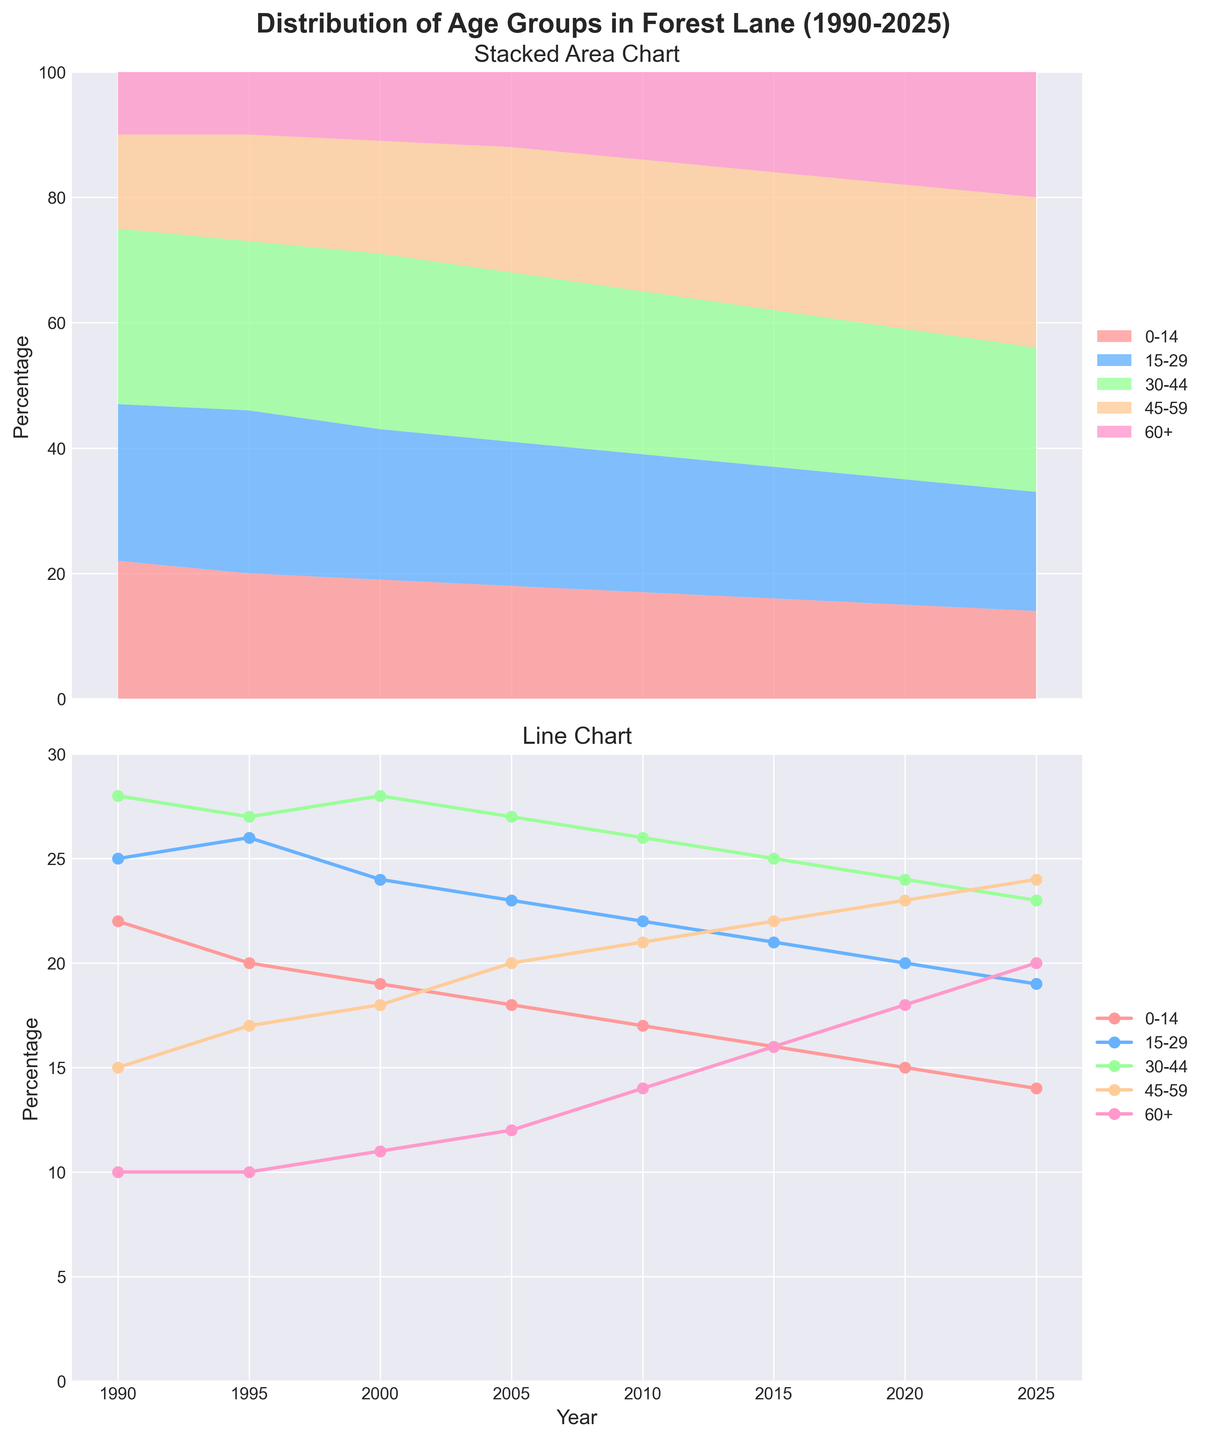What age group experienced the largest increase in percentage from 1990 to 2025? To find the age group with the largest increase, subtract the 1990 percentage from the 2025 percentage for each group: (14-22)=(-8); (19-25)=(-6); (23-28)=(-5); (24-15)=(9); (20-10)=(10). The 60+ group had the largest increase.
Answer: 60+ Which age group shows a consistent decrease over all the years? To determine the age group with a consistent decrease, observe the values across all years for each age group. Only the 0-14 group's percentage consistently decreases from 22 in 1990 to 14 in 2025.
Answer: 0-14 During which period did the 45-59 age group experience the most significant increase? To detect the period with the most significant increase for the 45-59 age group, calculate the differences between consecutive years: 1990-1995: 17-15=2; 1995-2000: 18-17=1; 2000-2005: 20-18=2; 2005-2010: 21-20=1; 2010-2015: 22-21=1; 2015-2020: 23-22=1; 2020-2025: 24-23=1. The most significant increase was from 2000 to 2005.
Answer: 2000-2005 What is the average percentage of the 15-29 age group from 1990 to 2025? Sum the percentages of the 15-29 age group for all the years and divide by the number of data points: (25+26+24+23+22+21+20+19)/8 = 180/8 = 22.5.
Answer: 22.5 Which two age groups had the closest percentages in 2010? Compare the percentages of each age group in 2010: 0-14:17; 15-29:22; 30-44:26; 45-59:21; 60+:14. The closest difference is between 45-59 and 15-29, with a difference of 1 (22-21).
Answer: 45-59 and 15-29 In what year did the percentage of the 30-44 age group peak? Examine the plot and observe the trend of the 30-44 age group. The highest value is 28, and it appears in both 1990 and 2000.
Answer: 1990 and 2000 By how many percentage points did the 0-14 age group percentage drop from 1990 to 2025? Subtract the percentage of the 0-14 group in 2025 from 1990: 1990:22 - 2025:14 = 8. Therefore, the drop is 8 percentage points.
Answer: 8 What is the total percentage of the 30-44 and 45-59 age groups combined in 2020? Add the percentages of the 30-44 and 45-59 groups in 2020: 24 + 23 = 47.
Answer: 47 Which age group had the smallest percentage in 2005? In 2005, the percentages are as follows: 0-14:18; 15-29:23; 30-44:27; 45-59:20; 60+:12. The smallest percentage is in the 60+ group.
Answer: 60+ What is the trend of the percentage of the 60+ age group from 1990 to 2025? Observe the trend of the 60+ line in the plot. The percentage consistently increases from 10% in 1990 to 20% in 2025.
Answer: Increasing 